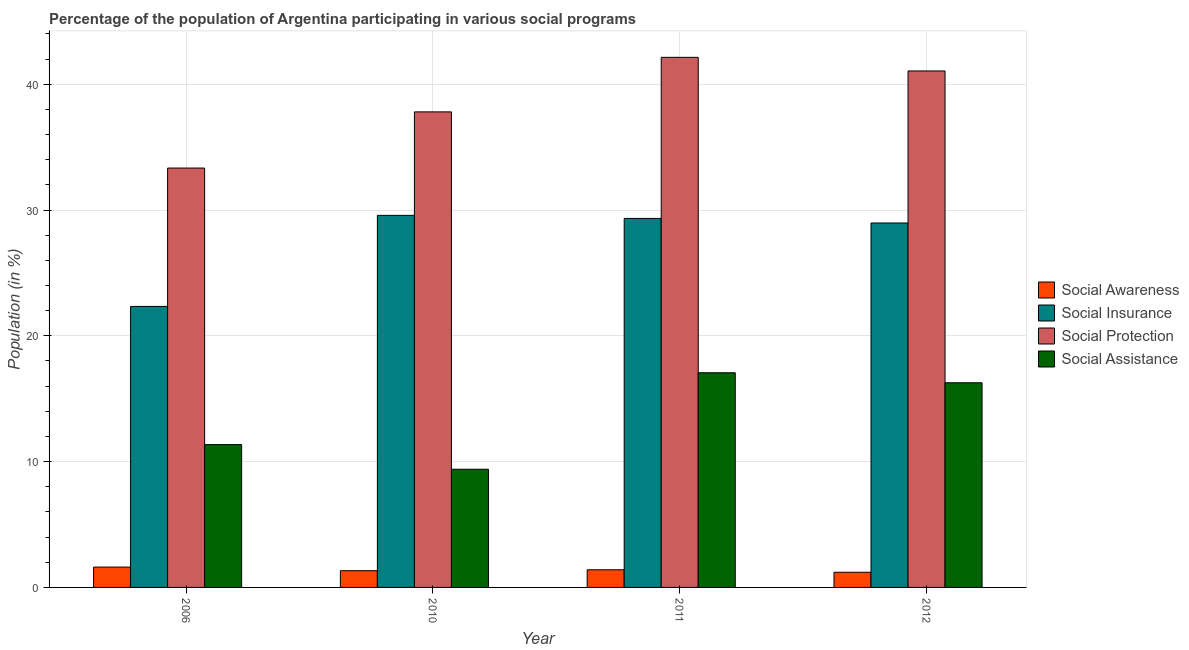How many groups of bars are there?
Offer a terse response. 4. Are the number of bars per tick equal to the number of legend labels?
Provide a short and direct response. Yes. Are the number of bars on each tick of the X-axis equal?
Provide a short and direct response. Yes. How many bars are there on the 4th tick from the left?
Make the answer very short. 4. What is the label of the 4th group of bars from the left?
Offer a terse response. 2012. In how many cases, is the number of bars for a given year not equal to the number of legend labels?
Provide a short and direct response. 0. What is the participation of population in social assistance programs in 2011?
Make the answer very short. 17.06. Across all years, what is the maximum participation of population in social assistance programs?
Give a very brief answer. 17.06. Across all years, what is the minimum participation of population in social awareness programs?
Keep it short and to the point. 1.21. What is the total participation of population in social assistance programs in the graph?
Keep it short and to the point. 54.08. What is the difference between the participation of population in social assistance programs in 2006 and that in 2010?
Provide a succinct answer. 1.96. What is the difference between the participation of population in social awareness programs in 2010 and the participation of population in social protection programs in 2011?
Ensure brevity in your answer.  -0.07. What is the average participation of population in social assistance programs per year?
Your answer should be compact. 13.52. What is the ratio of the participation of population in social insurance programs in 2006 to that in 2012?
Your response must be concise. 0.77. Is the participation of population in social insurance programs in 2006 less than that in 2012?
Offer a terse response. Yes. Is the difference between the participation of population in social insurance programs in 2011 and 2012 greater than the difference between the participation of population in social awareness programs in 2011 and 2012?
Your answer should be compact. No. What is the difference between the highest and the second highest participation of population in social assistance programs?
Offer a terse response. 0.79. What is the difference between the highest and the lowest participation of population in social insurance programs?
Your response must be concise. 7.24. In how many years, is the participation of population in social insurance programs greater than the average participation of population in social insurance programs taken over all years?
Offer a very short reply. 3. Is it the case that in every year, the sum of the participation of population in social insurance programs and participation of population in social protection programs is greater than the sum of participation of population in social assistance programs and participation of population in social awareness programs?
Make the answer very short. No. What does the 4th bar from the left in 2011 represents?
Ensure brevity in your answer.  Social Assistance. What does the 1st bar from the right in 2012 represents?
Ensure brevity in your answer.  Social Assistance. Is it the case that in every year, the sum of the participation of population in social awareness programs and participation of population in social insurance programs is greater than the participation of population in social protection programs?
Your answer should be compact. No. How many bars are there?
Your answer should be very brief. 16. Are all the bars in the graph horizontal?
Give a very brief answer. No. How many years are there in the graph?
Offer a terse response. 4. Does the graph contain any zero values?
Give a very brief answer. No. Where does the legend appear in the graph?
Your answer should be very brief. Center right. How are the legend labels stacked?
Give a very brief answer. Vertical. What is the title of the graph?
Provide a succinct answer. Percentage of the population of Argentina participating in various social programs . Does "Social Protection" appear as one of the legend labels in the graph?
Ensure brevity in your answer.  Yes. What is the label or title of the X-axis?
Offer a very short reply. Year. What is the Population (in %) in Social Awareness in 2006?
Give a very brief answer. 1.62. What is the Population (in %) in Social Insurance in 2006?
Your response must be concise. 22.34. What is the Population (in %) in Social Protection in 2006?
Ensure brevity in your answer.  33.34. What is the Population (in %) in Social Assistance in 2006?
Your response must be concise. 11.35. What is the Population (in %) in Social Awareness in 2010?
Provide a succinct answer. 1.33. What is the Population (in %) of Social Insurance in 2010?
Provide a succinct answer. 29.58. What is the Population (in %) in Social Protection in 2010?
Keep it short and to the point. 37.8. What is the Population (in %) of Social Assistance in 2010?
Give a very brief answer. 9.39. What is the Population (in %) of Social Awareness in 2011?
Provide a succinct answer. 1.4. What is the Population (in %) in Social Insurance in 2011?
Your answer should be very brief. 29.33. What is the Population (in %) in Social Protection in 2011?
Give a very brief answer. 42.14. What is the Population (in %) of Social Assistance in 2011?
Offer a very short reply. 17.06. What is the Population (in %) of Social Awareness in 2012?
Provide a succinct answer. 1.21. What is the Population (in %) of Social Insurance in 2012?
Make the answer very short. 28.97. What is the Population (in %) of Social Protection in 2012?
Make the answer very short. 41.05. What is the Population (in %) of Social Assistance in 2012?
Keep it short and to the point. 16.27. Across all years, what is the maximum Population (in %) of Social Awareness?
Your response must be concise. 1.62. Across all years, what is the maximum Population (in %) of Social Insurance?
Give a very brief answer. 29.58. Across all years, what is the maximum Population (in %) of Social Protection?
Offer a very short reply. 42.14. Across all years, what is the maximum Population (in %) of Social Assistance?
Ensure brevity in your answer.  17.06. Across all years, what is the minimum Population (in %) of Social Awareness?
Your answer should be very brief. 1.21. Across all years, what is the minimum Population (in %) in Social Insurance?
Your response must be concise. 22.34. Across all years, what is the minimum Population (in %) in Social Protection?
Provide a short and direct response. 33.34. Across all years, what is the minimum Population (in %) of Social Assistance?
Keep it short and to the point. 9.39. What is the total Population (in %) in Social Awareness in the graph?
Give a very brief answer. 5.56. What is the total Population (in %) in Social Insurance in the graph?
Your answer should be very brief. 110.22. What is the total Population (in %) in Social Protection in the graph?
Keep it short and to the point. 154.33. What is the total Population (in %) of Social Assistance in the graph?
Keep it short and to the point. 54.08. What is the difference between the Population (in %) of Social Awareness in 2006 and that in 2010?
Ensure brevity in your answer.  0.28. What is the difference between the Population (in %) of Social Insurance in 2006 and that in 2010?
Ensure brevity in your answer.  -7.24. What is the difference between the Population (in %) in Social Protection in 2006 and that in 2010?
Provide a short and direct response. -4.47. What is the difference between the Population (in %) of Social Assistance in 2006 and that in 2010?
Your response must be concise. 1.96. What is the difference between the Population (in %) in Social Awareness in 2006 and that in 2011?
Your response must be concise. 0.21. What is the difference between the Population (in %) of Social Insurance in 2006 and that in 2011?
Provide a short and direct response. -6.99. What is the difference between the Population (in %) of Social Protection in 2006 and that in 2011?
Your answer should be compact. -8.8. What is the difference between the Population (in %) in Social Assistance in 2006 and that in 2011?
Keep it short and to the point. -5.71. What is the difference between the Population (in %) of Social Awareness in 2006 and that in 2012?
Offer a terse response. 0.41. What is the difference between the Population (in %) in Social Insurance in 2006 and that in 2012?
Keep it short and to the point. -6.63. What is the difference between the Population (in %) in Social Protection in 2006 and that in 2012?
Your response must be concise. -7.72. What is the difference between the Population (in %) in Social Assistance in 2006 and that in 2012?
Your response must be concise. -4.92. What is the difference between the Population (in %) in Social Awareness in 2010 and that in 2011?
Your response must be concise. -0.07. What is the difference between the Population (in %) of Social Insurance in 2010 and that in 2011?
Keep it short and to the point. 0.24. What is the difference between the Population (in %) in Social Protection in 2010 and that in 2011?
Offer a terse response. -4.34. What is the difference between the Population (in %) in Social Assistance in 2010 and that in 2011?
Your response must be concise. -7.67. What is the difference between the Population (in %) in Social Awareness in 2010 and that in 2012?
Ensure brevity in your answer.  0.13. What is the difference between the Population (in %) of Social Insurance in 2010 and that in 2012?
Give a very brief answer. 0.61. What is the difference between the Population (in %) in Social Protection in 2010 and that in 2012?
Keep it short and to the point. -3.25. What is the difference between the Population (in %) in Social Assistance in 2010 and that in 2012?
Provide a short and direct response. -6.88. What is the difference between the Population (in %) of Social Awareness in 2011 and that in 2012?
Provide a succinct answer. 0.2. What is the difference between the Population (in %) in Social Insurance in 2011 and that in 2012?
Provide a succinct answer. 0.36. What is the difference between the Population (in %) of Social Protection in 2011 and that in 2012?
Provide a short and direct response. 1.08. What is the difference between the Population (in %) of Social Assistance in 2011 and that in 2012?
Your answer should be compact. 0.79. What is the difference between the Population (in %) of Social Awareness in 2006 and the Population (in %) of Social Insurance in 2010?
Make the answer very short. -27.96. What is the difference between the Population (in %) of Social Awareness in 2006 and the Population (in %) of Social Protection in 2010?
Make the answer very short. -36.18. What is the difference between the Population (in %) of Social Awareness in 2006 and the Population (in %) of Social Assistance in 2010?
Provide a short and direct response. -7.78. What is the difference between the Population (in %) of Social Insurance in 2006 and the Population (in %) of Social Protection in 2010?
Offer a very short reply. -15.46. What is the difference between the Population (in %) in Social Insurance in 2006 and the Population (in %) in Social Assistance in 2010?
Your answer should be compact. 12.94. What is the difference between the Population (in %) in Social Protection in 2006 and the Population (in %) in Social Assistance in 2010?
Offer a terse response. 23.94. What is the difference between the Population (in %) in Social Awareness in 2006 and the Population (in %) in Social Insurance in 2011?
Your answer should be very brief. -27.72. What is the difference between the Population (in %) in Social Awareness in 2006 and the Population (in %) in Social Protection in 2011?
Provide a short and direct response. -40.52. What is the difference between the Population (in %) in Social Awareness in 2006 and the Population (in %) in Social Assistance in 2011?
Offer a terse response. -15.45. What is the difference between the Population (in %) in Social Insurance in 2006 and the Population (in %) in Social Protection in 2011?
Your answer should be very brief. -19.8. What is the difference between the Population (in %) of Social Insurance in 2006 and the Population (in %) of Social Assistance in 2011?
Provide a succinct answer. 5.27. What is the difference between the Population (in %) in Social Protection in 2006 and the Population (in %) in Social Assistance in 2011?
Your answer should be very brief. 16.27. What is the difference between the Population (in %) in Social Awareness in 2006 and the Population (in %) in Social Insurance in 2012?
Give a very brief answer. -27.35. What is the difference between the Population (in %) of Social Awareness in 2006 and the Population (in %) of Social Protection in 2012?
Provide a short and direct response. -39.44. What is the difference between the Population (in %) in Social Awareness in 2006 and the Population (in %) in Social Assistance in 2012?
Ensure brevity in your answer.  -14.65. What is the difference between the Population (in %) in Social Insurance in 2006 and the Population (in %) in Social Protection in 2012?
Keep it short and to the point. -18.72. What is the difference between the Population (in %) in Social Insurance in 2006 and the Population (in %) in Social Assistance in 2012?
Give a very brief answer. 6.07. What is the difference between the Population (in %) in Social Protection in 2006 and the Population (in %) in Social Assistance in 2012?
Your response must be concise. 17.07. What is the difference between the Population (in %) in Social Awareness in 2010 and the Population (in %) in Social Insurance in 2011?
Keep it short and to the point. -28. What is the difference between the Population (in %) in Social Awareness in 2010 and the Population (in %) in Social Protection in 2011?
Make the answer very short. -40.81. What is the difference between the Population (in %) in Social Awareness in 2010 and the Population (in %) in Social Assistance in 2011?
Offer a terse response. -15.73. What is the difference between the Population (in %) in Social Insurance in 2010 and the Population (in %) in Social Protection in 2011?
Provide a short and direct response. -12.56. What is the difference between the Population (in %) in Social Insurance in 2010 and the Population (in %) in Social Assistance in 2011?
Offer a terse response. 12.51. What is the difference between the Population (in %) in Social Protection in 2010 and the Population (in %) in Social Assistance in 2011?
Make the answer very short. 20.74. What is the difference between the Population (in %) of Social Awareness in 2010 and the Population (in %) of Social Insurance in 2012?
Offer a terse response. -27.64. What is the difference between the Population (in %) in Social Awareness in 2010 and the Population (in %) in Social Protection in 2012?
Give a very brief answer. -39.72. What is the difference between the Population (in %) of Social Awareness in 2010 and the Population (in %) of Social Assistance in 2012?
Provide a short and direct response. -14.94. What is the difference between the Population (in %) in Social Insurance in 2010 and the Population (in %) in Social Protection in 2012?
Your response must be concise. -11.48. What is the difference between the Population (in %) of Social Insurance in 2010 and the Population (in %) of Social Assistance in 2012?
Offer a very short reply. 13.31. What is the difference between the Population (in %) in Social Protection in 2010 and the Population (in %) in Social Assistance in 2012?
Ensure brevity in your answer.  21.53. What is the difference between the Population (in %) in Social Awareness in 2011 and the Population (in %) in Social Insurance in 2012?
Provide a short and direct response. -27.57. What is the difference between the Population (in %) of Social Awareness in 2011 and the Population (in %) of Social Protection in 2012?
Provide a short and direct response. -39.65. What is the difference between the Population (in %) of Social Awareness in 2011 and the Population (in %) of Social Assistance in 2012?
Your answer should be very brief. -14.87. What is the difference between the Population (in %) of Social Insurance in 2011 and the Population (in %) of Social Protection in 2012?
Offer a terse response. -11.72. What is the difference between the Population (in %) in Social Insurance in 2011 and the Population (in %) in Social Assistance in 2012?
Your response must be concise. 13.06. What is the difference between the Population (in %) of Social Protection in 2011 and the Population (in %) of Social Assistance in 2012?
Offer a very short reply. 25.87. What is the average Population (in %) in Social Awareness per year?
Offer a very short reply. 1.39. What is the average Population (in %) of Social Insurance per year?
Ensure brevity in your answer.  27.55. What is the average Population (in %) of Social Protection per year?
Make the answer very short. 38.58. What is the average Population (in %) of Social Assistance per year?
Make the answer very short. 13.52. In the year 2006, what is the difference between the Population (in %) in Social Awareness and Population (in %) in Social Insurance?
Offer a terse response. -20.72. In the year 2006, what is the difference between the Population (in %) of Social Awareness and Population (in %) of Social Protection?
Keep it short and to the point. -31.72. In the year 2006, what is the difference between the Population (in %) of Social Awareness and Population (in %) of Social Assistance?
Keep it short and to the point. -9.74. In the year 2006, what is the difference between the Population (in %) in Social Insurance and Population (in %) in Social Protection?
Your response must be concise. -11. In the year 2006, what is the difference between the Population (in %) of Social Insurance and Population (in %) of Social Assistance?
Provide a succinct answer. 10.98. In the year 2006, what is the difference between the Population (in %) of Social Protection and Population (in %) of Social Assistance?
Provide a succinct answer. 21.98. In the year 2010, what is the difference between the Population (in %) in Social Awareness and Population (in %) in Social Insurance?
Your response must be concise. -28.24. In the year 2010, what is the difference between the Population (in %) of Social Awareness and Population (in %) of Social Protection?
Keep it short and to the point. -36.47. In the year 2010, what is the difference between the Population (in %) of Social Awareness and Population (in %) of Social Assistance?
Provide a succinct answer. -8.06. In the year 2010, what is the difference between the Population (in %) in Social Insurance and Population (in %) in Social Protection?
Your response must be concise. -8.23. In the year 2010, what is the difference between the Population (in %) in Social Insurance and Population (in %) in Social Assistance?
Your response must be concise. 20.18. In the year 2010, what is the difference between the Population (in %) in Social Protection and Population (in %) in Social Assistance?
Provide a succinct answer. 28.41. In the year 2011, what is the difference between the Population (in %) in Social Awareness and Population (in %) in Social Insurance?
Make the answer very short. -27.93. In the year 2011, what is the difference between the Population (in %) of Social Awareness and Population (in %) of Social Protection?
Make the answer very short. -40.73. In the year 2011, what is the difference between the Population (in %) of Social Awareness and Population (in %) of Social Assistance?
Your answer should be compact. -15.66. In the year 2011, what is the difference between the Population (in %) in Social Insurance and Population (in %) in Social Protection?
Ensure brevity in your answer.  -12.81. In the year 2011, what is the difference between the Population (in %) in Social Insurance and Population (in %) in Social Assistance?
Your response must be concise. 12.27. In the year 2011, what is the difference between the Population (in %) in Social Protection and Population (in %) in Social Assistance?
Make the answer very short. 25.07. In the year 2012, what is the difference between the Population (in %) in Social Awareness and Population (in %) in Social Insurance?
Provide a short and direct response. -27.76. In the year 2012, what is the difference between the Population (in %) of Social Awareness and Population (in %) of Social Protection?
Your response must be concise. -39.85. In the year 2012, what is the difference between the Population (in %) in Social Awareness and Population (in %) in Social Assistance?
Ensure brevity in your answer.  -15.06. In the year 2012, what is the difference between the Population (in %) of Social Insurance and Population (in %) of Social Protection?
Give a very brief answer. -12.09. In the year 2012, what is the difference between the Population (in %) in Social Insurance and Population (in %) in Social Assistance?
Provide a short and direct response. 12.7. In the year 2012, what is the difference between the Population (in %) in Social Protection and Population (in %) in Social Assistance?
Give a very brief answer. 24.79. What is the ratio of the Population (in %) in Social Awareness in 2006 to that in 2010?
Ensure brevity in your answer.  1.21. What is the ratio of the Population (in %) of Social Insurance in 2006 to that in 2010?
Your answer should be compact. 0.76. What is the ratio of the Population (in %) of Social Protection in 2006 to that in 2010?
Offer a terse response. 0.88. What is the ratio of the Population (in %) of Social Assistance in 2006 to that in 2010?
Provide a succinct answer. 1.21. What is the ratio of the Population (in %) of Social Awareness in 2006 to that in 2011?
Your answer should be compact. 1.15. What is the ratio of the Population (in %) in Social Insurance in 2006 to that in 2011?
Make the answer very short. 0.76. What is the ratio of the Population (in %) of Social Protection in 2006 to that in 2011?
Give a very brief answer. 0.79. What is the ratio of the Population (in %) of Social Assistance in 2006 to that in 2011?
Your answer should be very brief. 0.67. What is the ratio of the Population (in %) in Social Awareness in 2006 to that in 2012?
Provide a short and direct response. 1.34. What is the ratio of the Population (in %) of Social Insurance in 2006 to that in 2012?
Make the answer very short. 0.77. What is the ratio of the Population (in %) of Social Protection in 2006 to that in 2012?
Offer a terse response. 0.81. What is the ratio of the Population (in %) of Social Assistance in 2006 to that in 2012?
Your answer should be compact. 0.7. What is the ratio of the Population (in %) in Social Awareness in 2010 to that in 2011?
Give a very brief answer. 0.95. What is the ratio of the Population (in %) in Social Insurance in 2010 to that in 2011?
Your response must be concise. 1.01. What is the ratio of the Population (in %) of Social Protection in 2010 to that in 2011?
Your answer should be compact. 0.9. What is the ratio of the Population (in %) of Social Assistance in 2010 to that in 2011?
Give a very brief answer. 0.55. What is the ratio of the Population (in %) of Social Awareness in 2010 to that in 2012?
Your answer should be compact. 1.1. What is the ratio of the Population (in %) of Social Insurance in 2010 to that in 2012?
Your response must be concise. 1.02. What is the ratio of the Population (in %) in Social Protection in 2010 to that in 2012?
Offer a terse response. 0.92. What is the ratio of the Population (in %) in Social Assistance in 2010 to that in 2012?
Provide a short and direct response. 0.58. What is the ratio of the Population (in %) of Social Awareness in 2011 to that in 2012?
Your answer should be compact. 1.16. What is the ratio of the Population (in %) of Social Insurance in 2011 to that in 2012?
Your response must be concise. 1.01. What is the ratio of the Population (in %) in Social Protection in 2011 to that in 2012?
Make the answer very short. 1.03. What is the ratio of the Population (in %) of Social Assistance in 2011 to that in 2012?
Keep it short and to the point. 1.05. What is the difference between the highest and the second highest Population (in %) of Social Awareness?
Keep it short and to the point. 0.21. What is the difference between the highest and the second highest Population (in %) in Social Insurance?
Offer a terse response. 0.24. What is the difference between the highest and the second highest Population (in %) of Social Protection?
Offer a very short reply. 1.08. What is the difference between the highest and the second highest Population (in %) of Social Assistance?
Give a very brief answer. 0.79. What is the difference between the highest and the lowest Population (in %) of Social Awareness?
Make the answer very short. 0.41. What is the difference between the highest and the lowest Population (in %) in Social Insurance?
Keep it short and to the point. 7.24. What is the difference between the highest and the lowest Population (in %) in Social Protection?
Your answer should be very brief. 8.8. What is the difference between the highest and the lowest Population (in %) in Social Assistance?
Give a very brief answer. 7.67. 